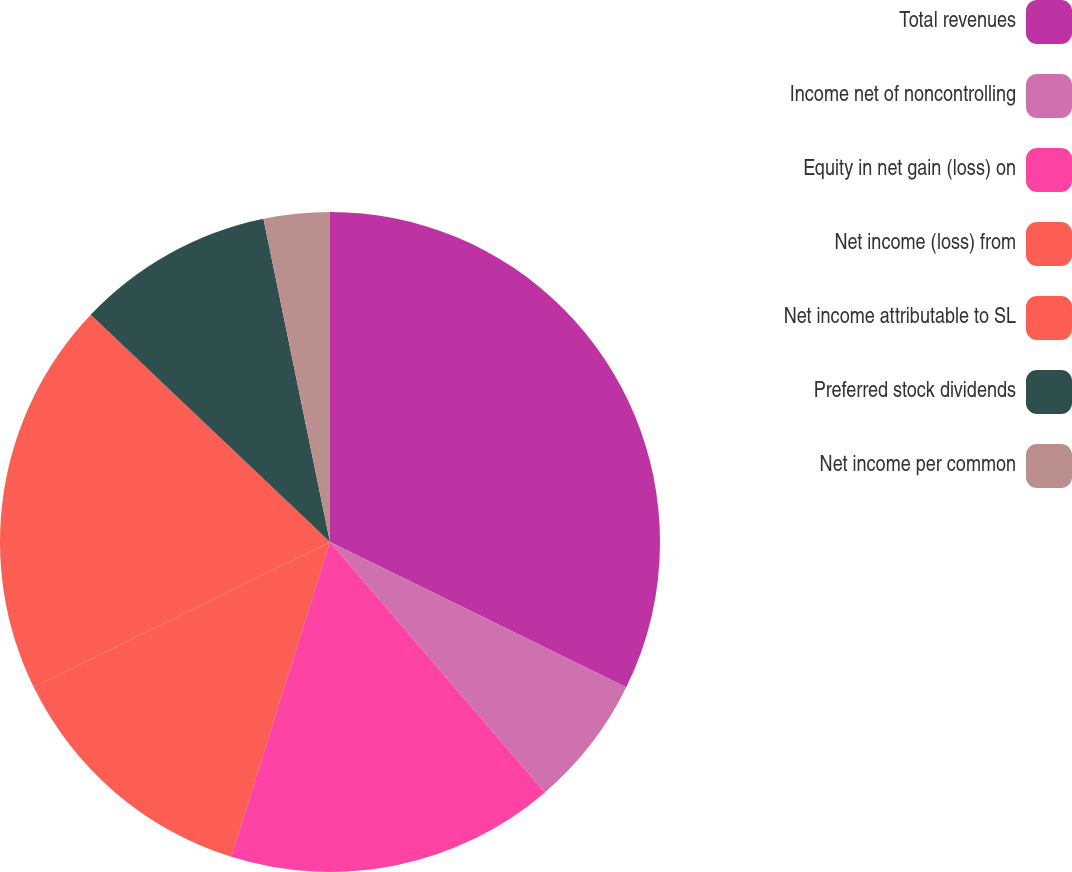Convert chart to OTSL. <chart><loc_0><loc_0><loc_500><loc_500><pie_chart><fcel>Total revenues<fcel>Income net of noncontrolling<fcel>Equity in net gain (loss) on<fcel>Net income (loss) from<fcel>Net income attributable to SL<fcel>Preferred stock dividends<fcel>Net income per common<nl><fcel>32.26%<fcel>6.45%<fcel>16.13%<fcel>12.9%<fcel>19.35%<fcel>9.68%<fcel>3.23%<nl></chart> 